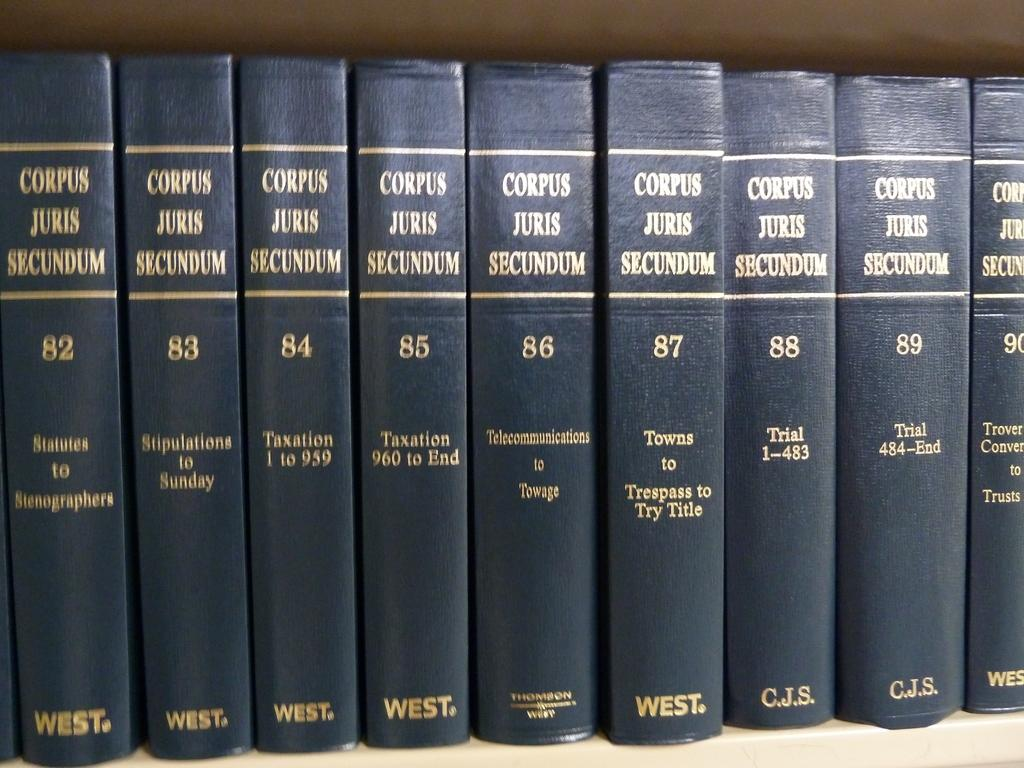Provide a one-sentence caption for the provided image. A collection of books called "Corpus Juris Sucundum" volumes 82 through 90 sit in a row. 